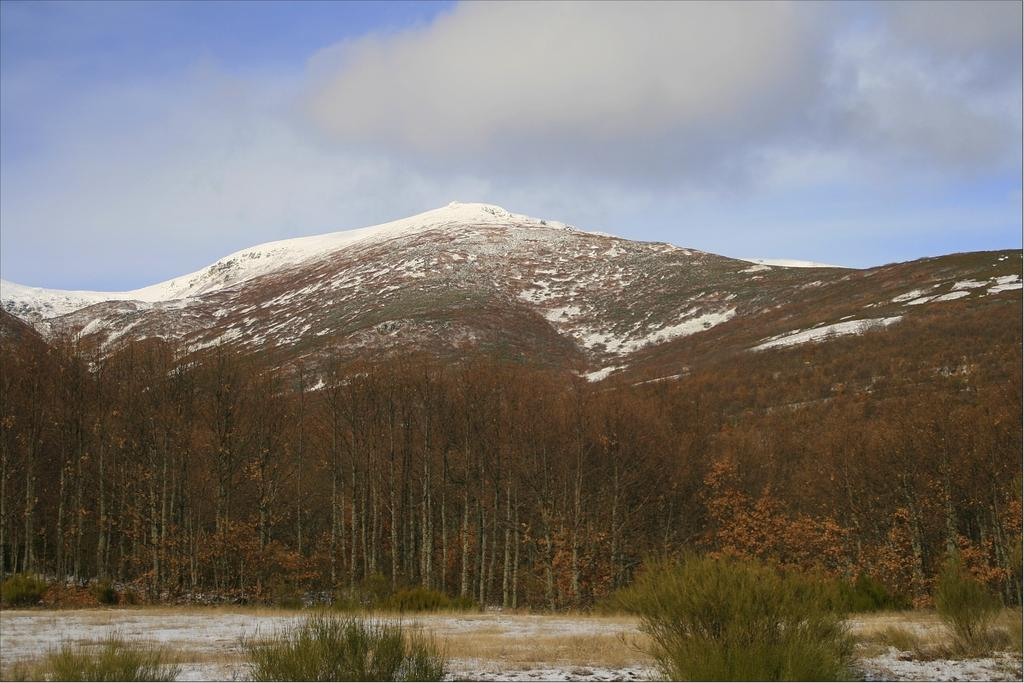What type of vegetation can be seen in the image? There are plants and trees in the image. What geographical feature is visible in the image? There are mountains in the image. What is the weather like in the image? There is snow visible in the image, and clouds are present in the sky, suggesting a cold and possibly snowy or overcast day. What is visible in the background of the image? The sky is visible in the background of the image. What type of pets can be seen playing in the snow in the image? There are no pets visible in the image; it only features plants, trees, mountains, snow, and clouds. 